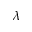<formula> <loc_0><loc_0><loc_500><loc_500>\lambda</formula> 